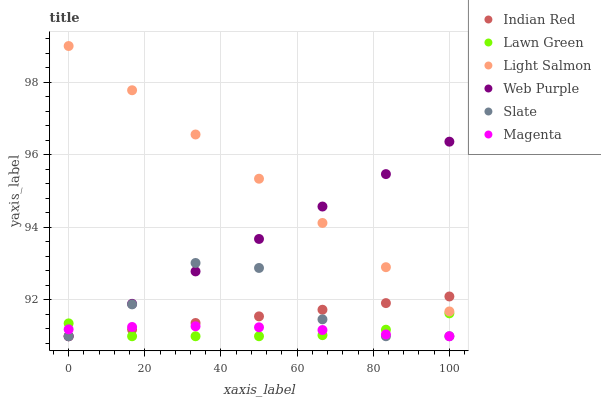Does Lawn Green have the minimum area under the curve?
Answer yes or no. Yes. Does Light Salmon have the maximum area under the curve?
Answer yes or no. Yes. Does Slate have the minimum area under the curve?
Answer yes or no. No. Does Slate have the maximum area under the curve?
Answer yes or no. No. Is Web Purple the smoothest?
Answer yes or no. Yes. Is Slate the roughest?
Answer yes or no. Yes. Is Light Salmon the smoothest?
Answer yes or no. No. Is Light Salmon the roughest?
Answer yes or no. No. Does Lawn Green have the lowest value?
Answer yes or no. Yes. Does Light Salmon have the lowest value?
Answer yes or no. No. Does Light Salmon have the highest value?
Answer yes or no. Yes. Does Slate have the highest value?
Answer yes or no. No. Is Magenta less than Light Salmon?
Answer yes or no. Yes. Is Light Salmon greater than Magenta?
Answer yes or no. Yes. Does Indian Red intersect Lawn Green?
Answer yes or no. Yes. Is Indian Red less than Lawn Green?
Answer yes or no. No. Is Indian Red greater than Lawn Green?
Answer yes or no. No. Does Magenta intersect Light Salmon?
Answer yes or no. No. 